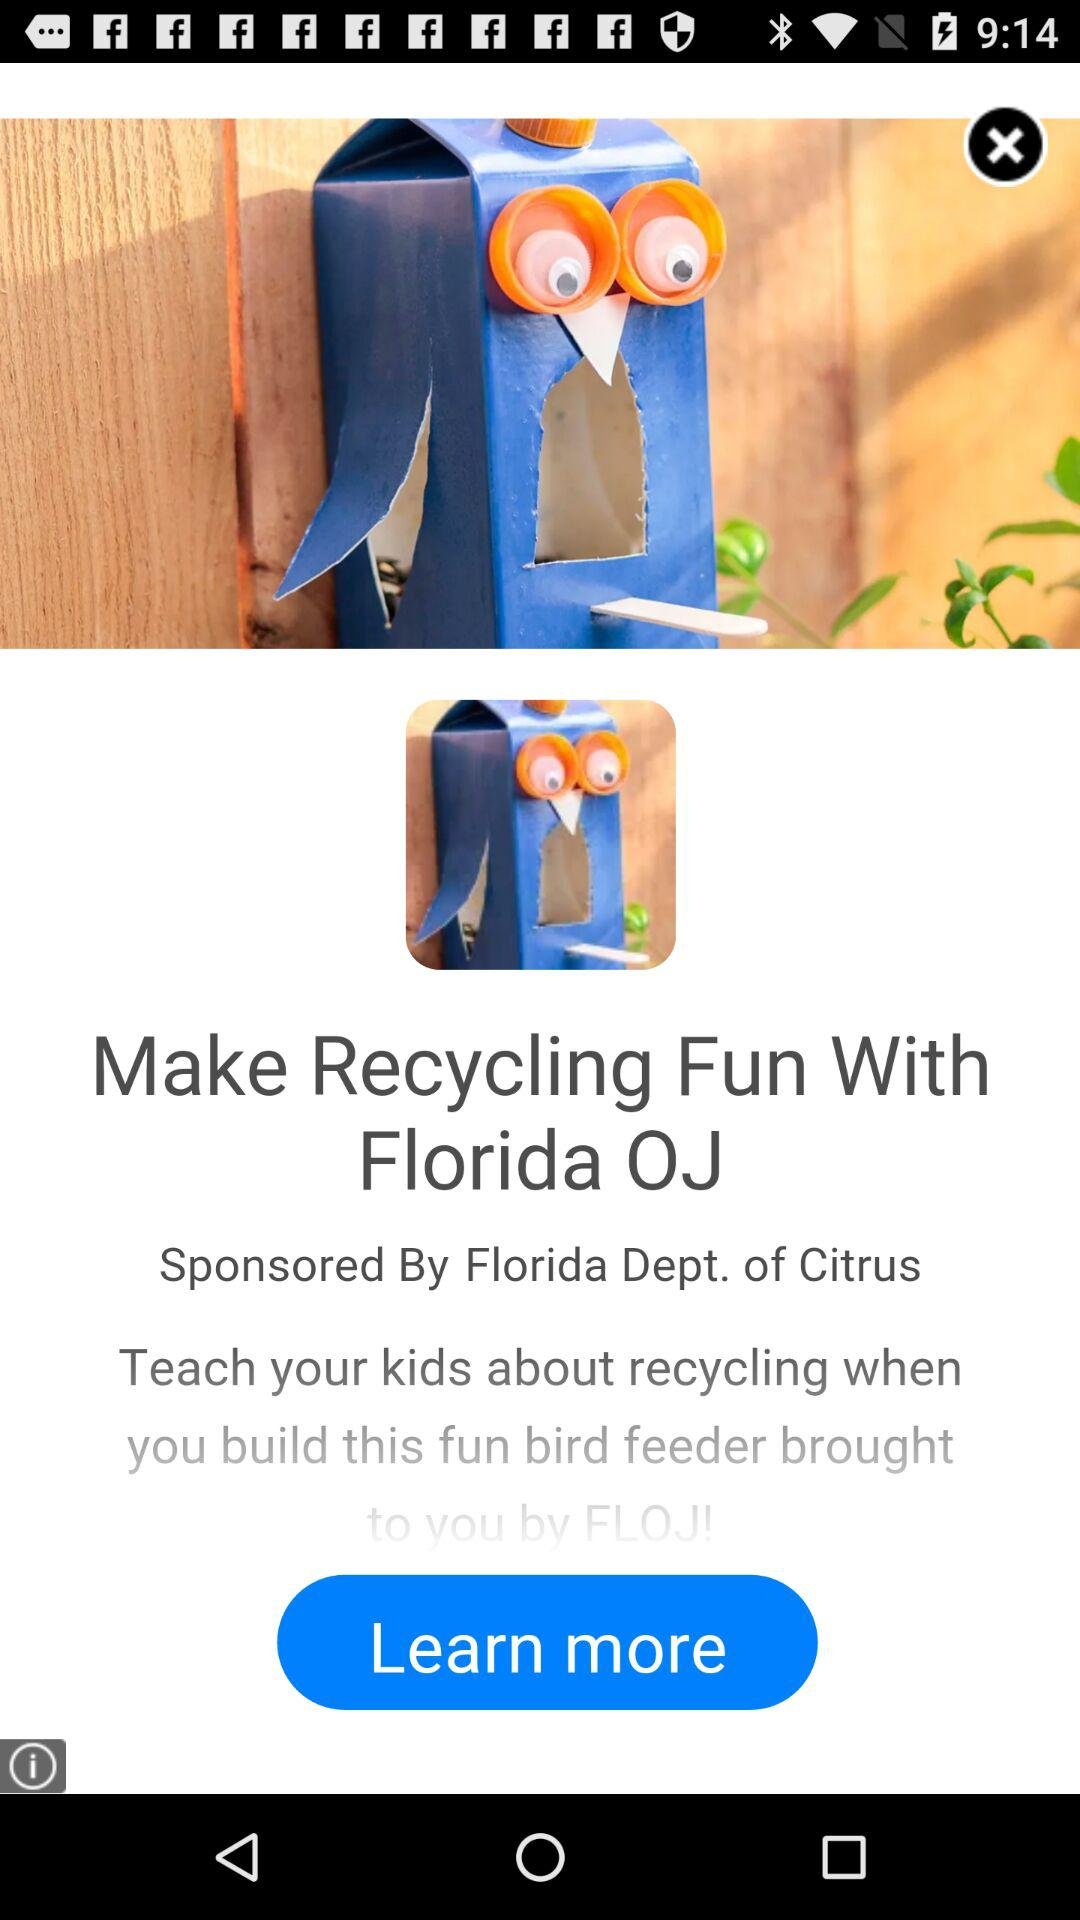Who sponsored the recycling fun? The recycling fun is sponsored by "Florida Dept. of Citrus". 